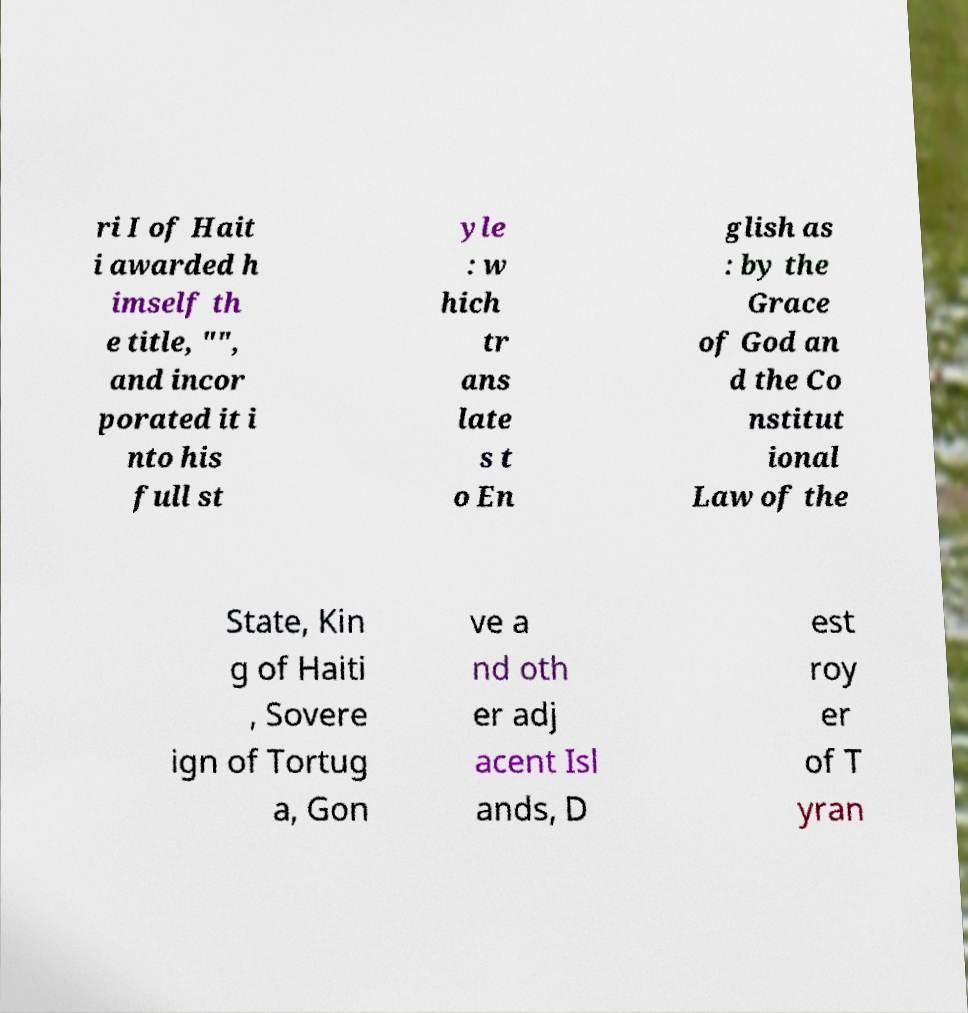There's text embedded in this image that I need extracted. Can you transcribe it verbatim? ri I of Hait i awarded h imself th e title, "", and incor porated it i nto his full st yle : w hich tr ans late s t o En glish as : by the Grace of God an d the Co nstitut ional Law of the State, Kin g of Haiti , Sovere ign of Tortug a, Gon ve a nd oth er adj acent Isl ands, D est roy er of T yran 